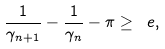Convert formula to latex. <formula><loc_0><loc_0><loc_500><loc_500>\frac { 1 } { \gamma _ { n + 1 } } - \frac { 1 } { \gamma _ { n } } - \pi \geq \ e ,</formula> 